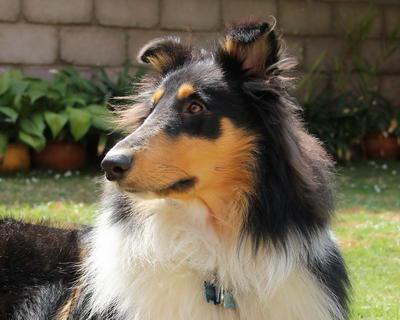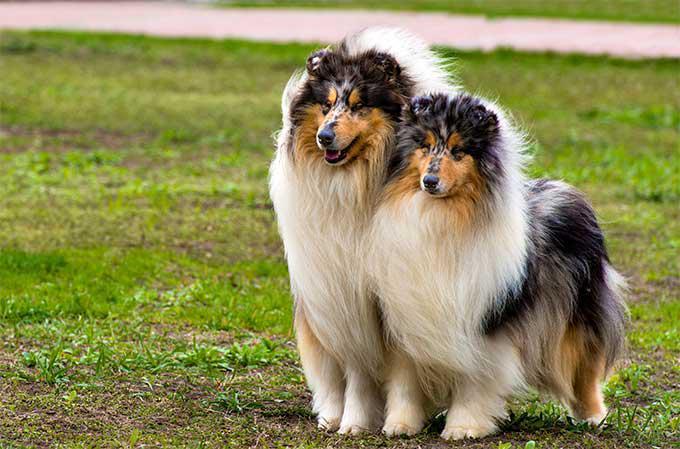The first image is the image on the left, the second image is the image on the right. Considering the images on both sides, is "There are more then one collie on the right image" valid? Answer yes or no. Yes. 